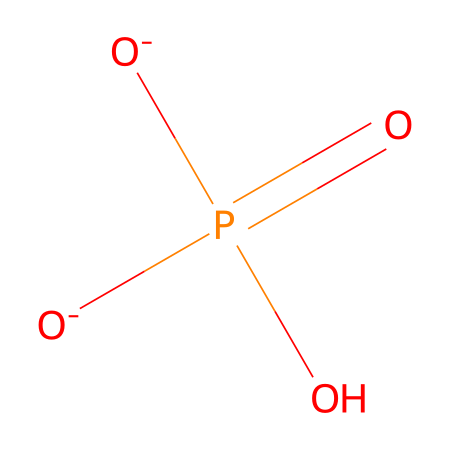What is the central atom in this chemical structure? The structure represents a phosphate group, where the phosphorus atom is at the center of the molecule, surrounded by four oxygen atoms.
Answer: phosphorus How many oxygen atoms are present in this phosphate structure? By examining the SMILES representation, there are four oxygen atoms attached to phosphorus; two are negatively charged, one is double-bonded, and one is a hydroxyl group.
Answer: four What type of bond connects phosphorus to the double-bonded oxygen? The chemical structure features a double bond between the phosphorus and one of the oxygen atoms, indicating it is a double bond.
Answer: double bond How does this phosphate structure contribute to buffer solutions? The phosphate group can accept or donate protons, enabling it to stabilize pH levels in biological systems, crucial for maintaining homeostasis.
Answer: stabilizes pH What specific functional group is present in this molecule? The structure contains phosphate functional groups, characterized by the presence of phosphorus bonded to oxygen atoms and hydroxyl groups.
Answer: phosphate What is the charge of the phosphate group in this structure? The representation shows that two oxygen atoms carry a negative charge, resulting in an overall charge of -2 for the phosphate group.
Answer: negative two How is the phosphate ion generally represented in biochemistry? In biochemistry, the phosphate ion is commonly represented as PO4 with the addition of a charge to indicate its function in energy transfer and buffering.
Answer: PO4 